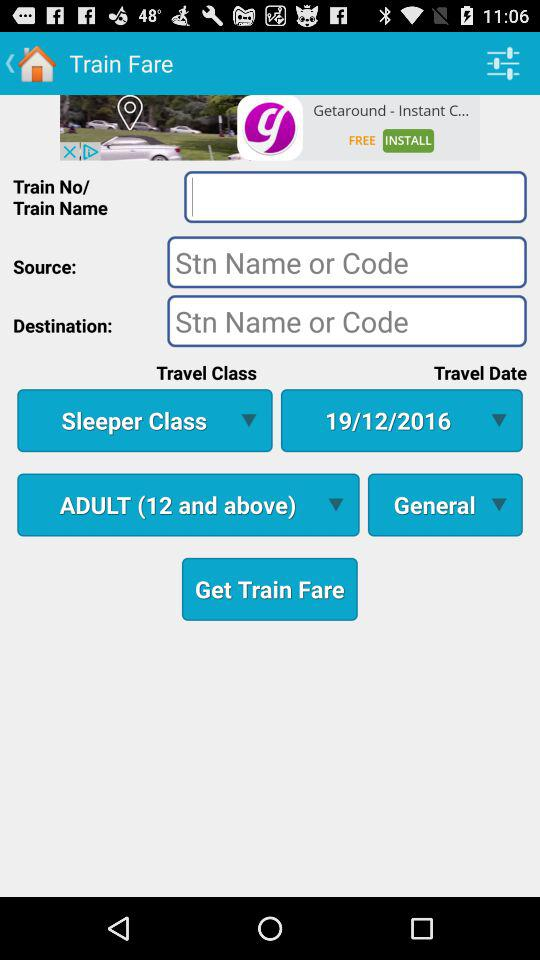What is the selected travel date? The selected travel date is December 19, 2016. 